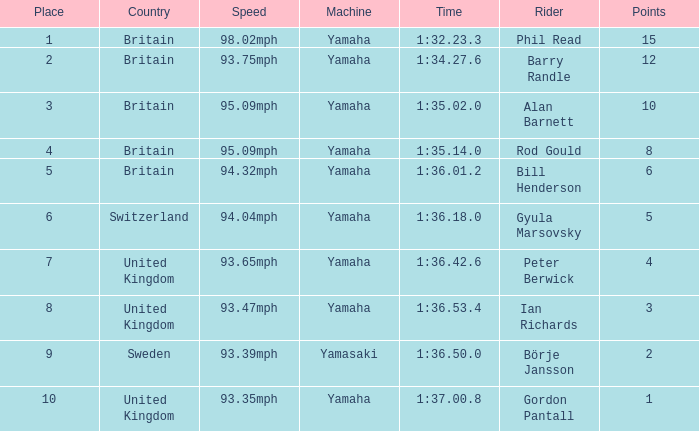What was the time for the man who scored 1 point? 1:37.00.8. 